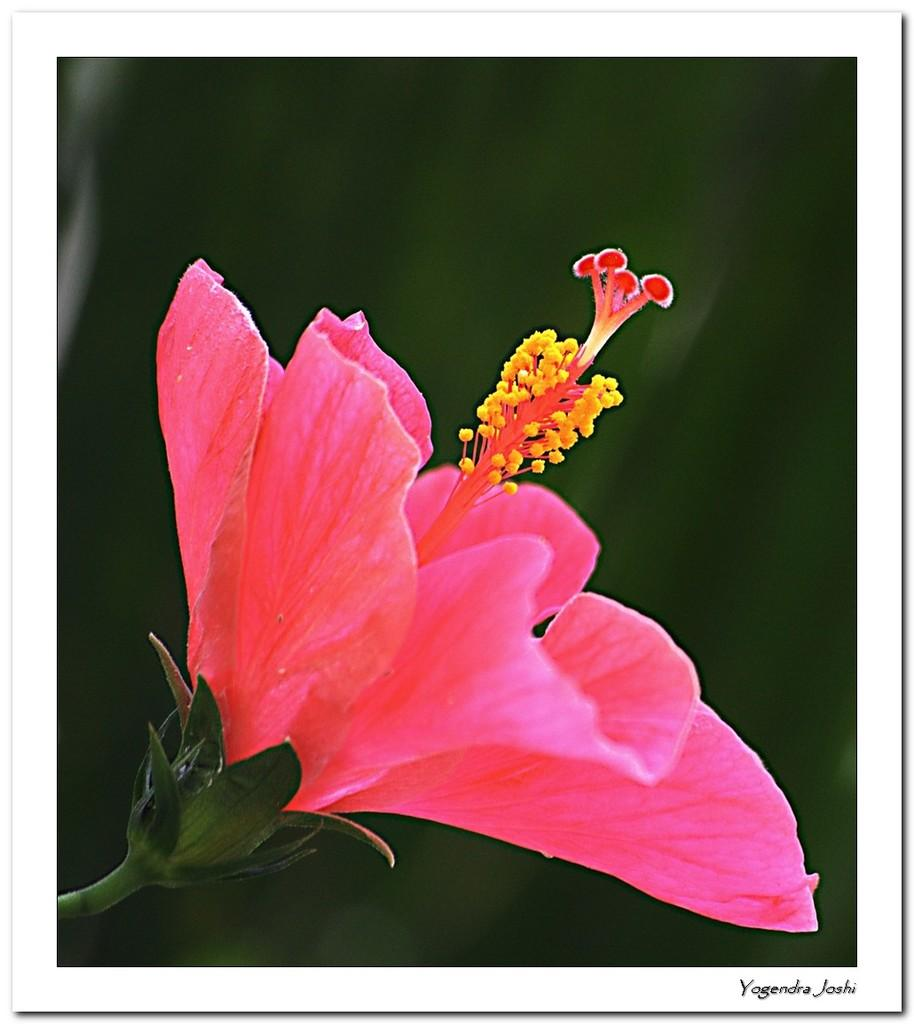What type of flower is in the image? There is a pink flower in the image. What color is the background of the image? The background of the image is green. Is there any text or label in the image? Yes, there is a name in the bottom right corner of the image. What is the income of the person who caused the coat to be in the image? There is no person, income, cause, or coat mentioned in the image, so this information cannot be determined. 